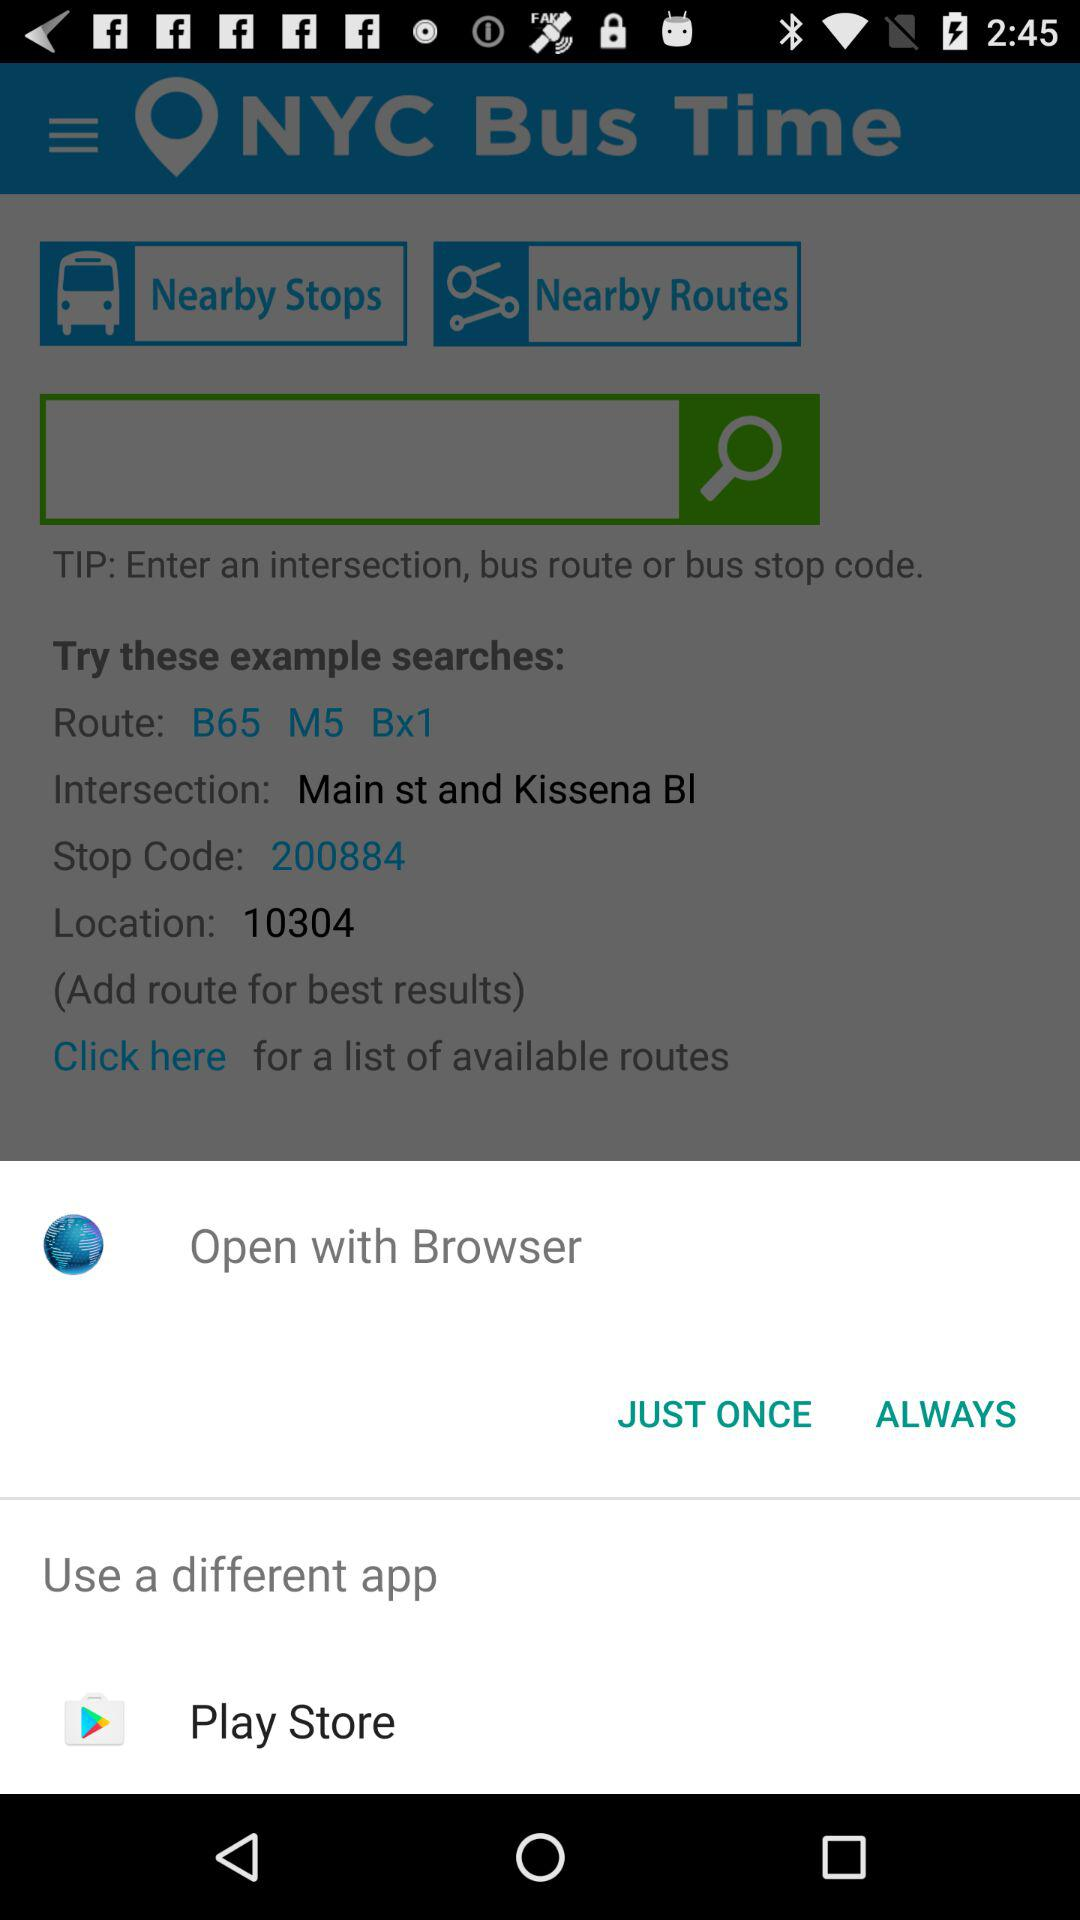What is the location's PIN code? The location's PIN code is 10304. 